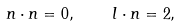<formula> <loc_0><loc_0><loc_500><loc_500>n \cdot n = 0 , \quad l \cdot n = 2 ,</formula> 